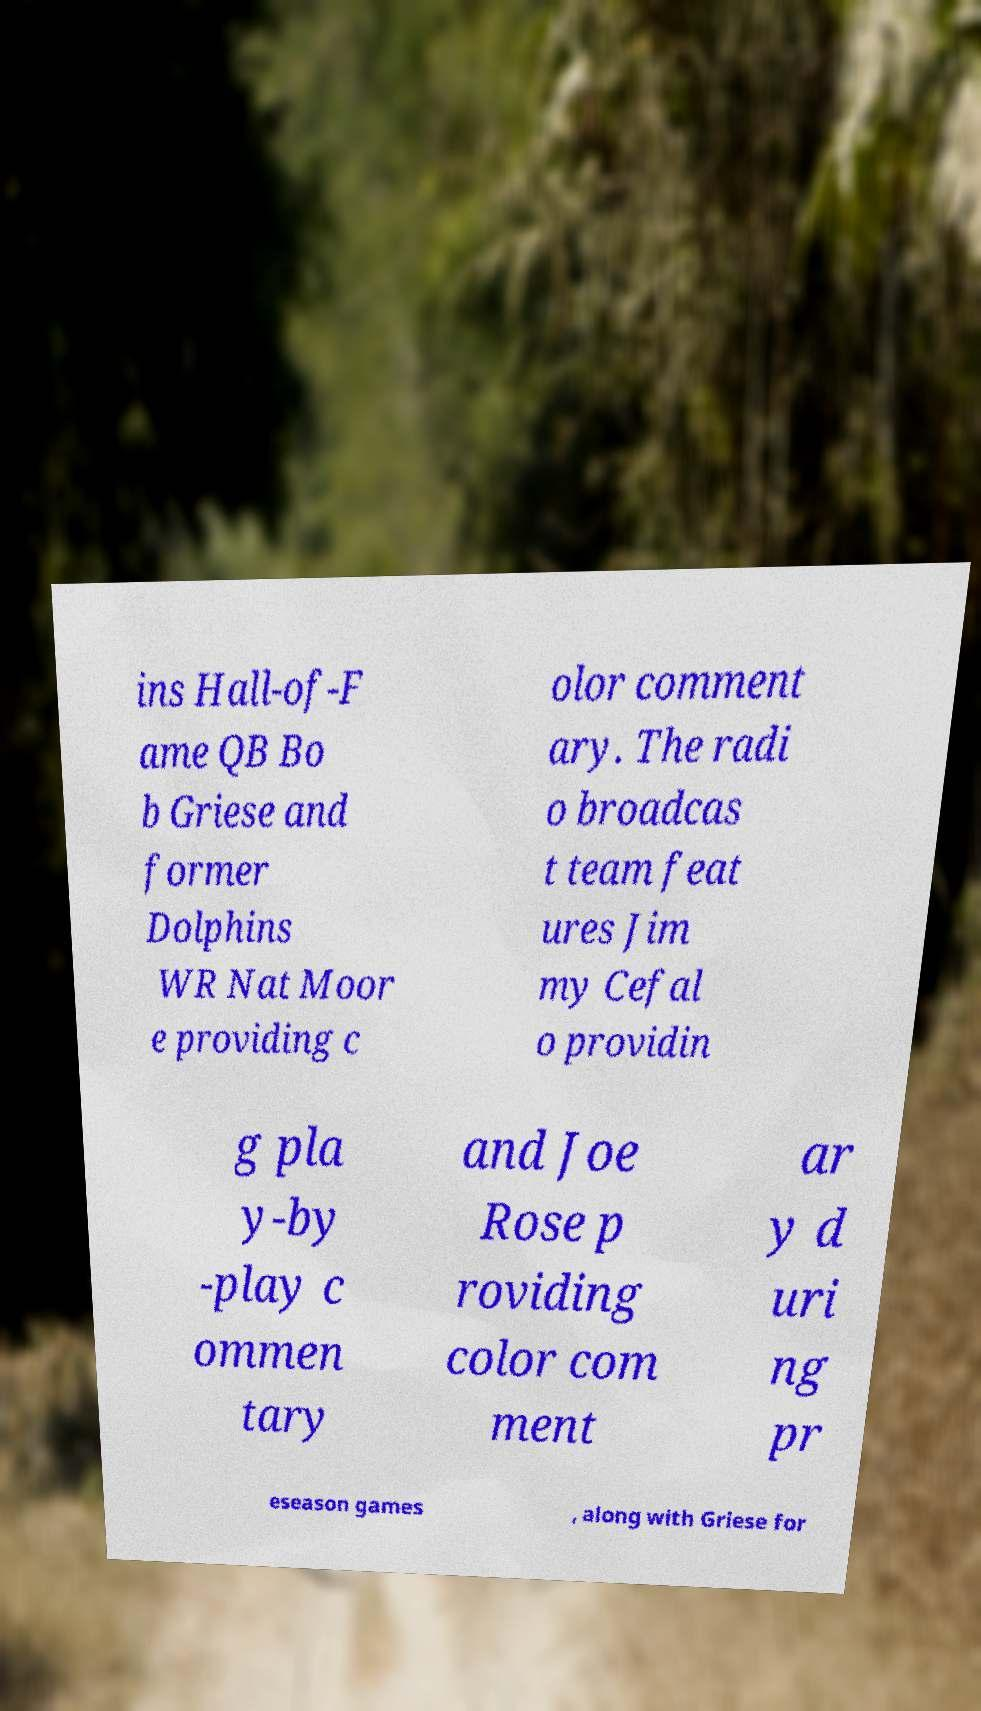Please read and relay the text visible in this image. What does it say? ins Hall-of-F ame QB Bo b Griese and former Dolphins WR Nat Moor e providing c olor comment ary. The radi o broadcas t team feat ures Jim my Cefal o providin g pla y-by -play c ommen tary and Joe Rose p roviding color com ment ar y d uri ng pr eseason games , along with Griese for 